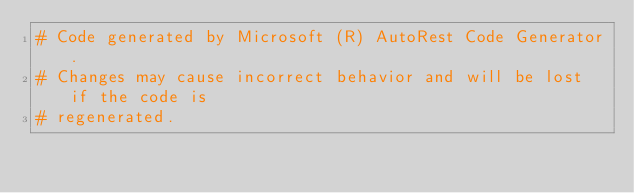Convert code to text. <code><loc_0><loc_0><loc_500><loc_500><_Ruby_># Code generated by Microsoft (R) AutoRest Code Generator.
# Changes may cause incorrect behavior and will be lost if the code is
# regenerated.
</code> 